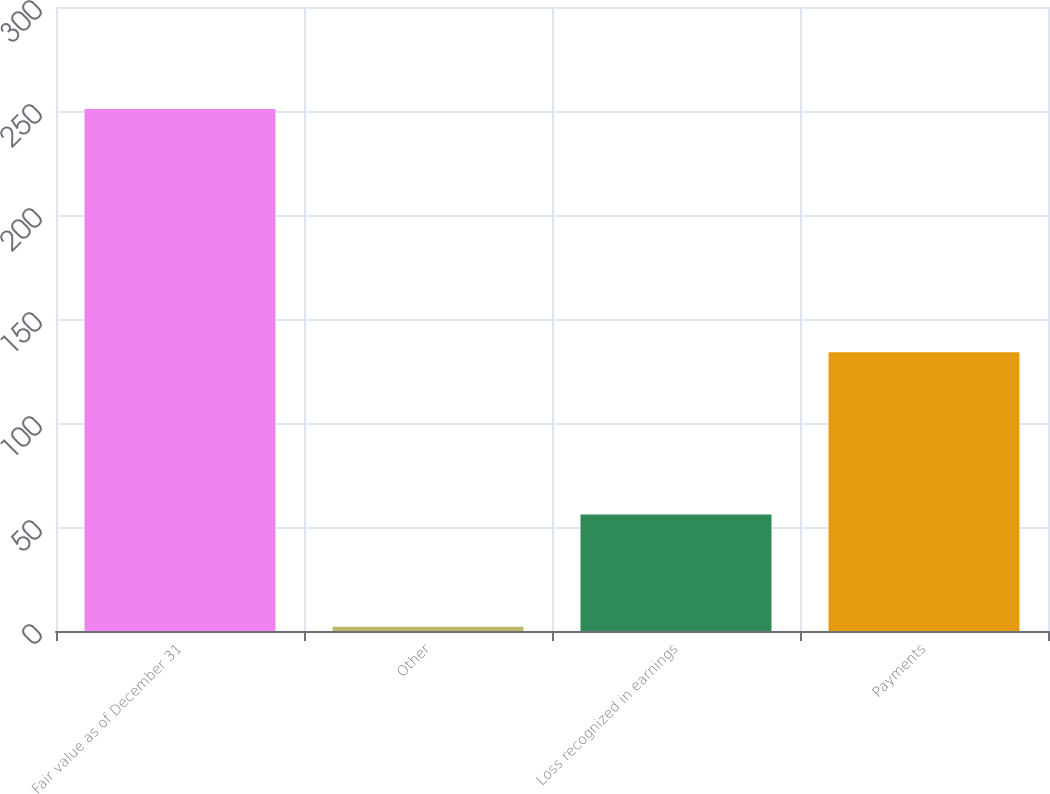Convert chart to OTSL. <chart><loc_0><loc_0><loc_500><loc_500><bar_chart><fcel>Fair value as of December 31<fcel>Other<fcel>Loss recognized in earnings<fcel>Payments<nl><fcel>251<fcel>2<fcel>56<fcel>134<nl></chart> 